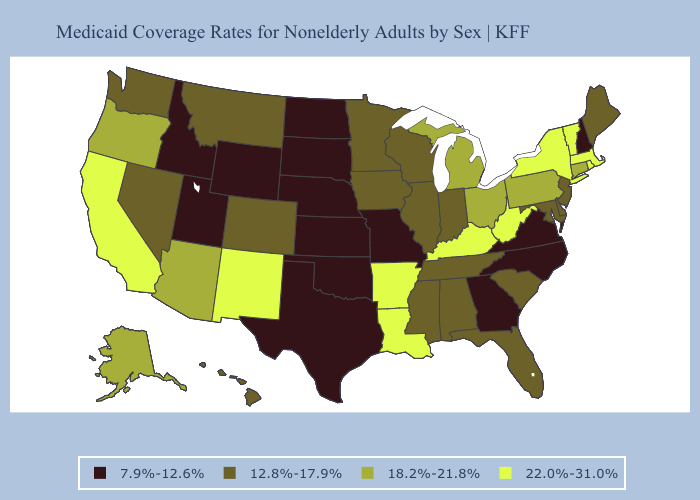Name the states that have a value in the range 18.2%-21.8%?
Quick response, please. Alaska, Arizona, Connecticut, Michigan, Ohio, Oregon, Pennsylvania. Among the states that border Illinois , does Wisconsin have the highest value?
Keep it brief. No. Which states have the lowest value in the USA?
Be succinct. Georgia, Idaho, Kansas, Missouri, Nebraska, New Hampshire, North Carolina, North Dakota, Oklahoma, South Dakota, Texas, Utah, Virginia, Wyoming. Which states have the highest value in the USA?
Answer briefly. Arkansas, California, Kentucky, Louisiana, Massachusetts, New Mexico, New York, Rhode Island, Vermont, West Virginia. How many symbols are there in the legend?
Write a very short answer. 4. Which states have the lowest value in the West?
Be succinct. Idaho, Utah, Wyoming. What is the value of Utah?
Short answer required. 7.9%-12.6%. Which states hav the highest value in the Northeast?
Be succinct. Massachusetts, New York, Rhode Island, Vermont. What is the value of New Jersey?
Write a very short answer. 12.8%-17.9%. Among the states that border Kansas , does Oklahoma have the lowest value?
Quick response, please. Yes. Among the states that border North Carolina , which have the lowest value?
Quick response, please. Georgia, Virginia. Among the states that border Arizona , which have the highest value?
Write a very short answer. California, New Mexico. Among the states that border Virginia , which have the highest value?
Give a very brief answer. Kentucky, West Virginia. Does the first symbol in the legend represent the smallest category?
Short answer required. Yes. Which states have the highest value in the USA?
Short answer required. Arkansas, California, Kentucky, Louisiana, Massachusetts, New Mexico, New York, Rhode Island, Vermont, West Virginia. 